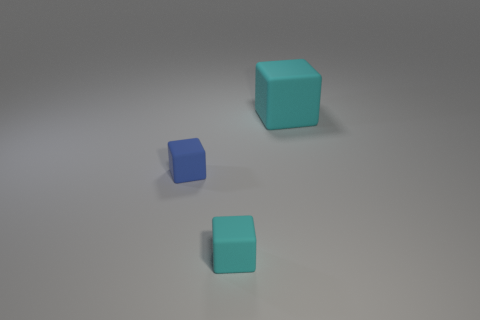Subtract all small cubes. How many cubes are left? 1 Add 1 tiny purple shiny balls. How many objects exist? 4 Subtract all purple cylinders. How many cyan cubes are left? 2 Subtract all blue cubes. How many cubes are left? 2 Subtract all small blue matte blocks. Subtract all large cyan things. How many objects are left? 1 Add 3 big blocks. How many big blocks are left? 4 Add 2 large brown blocks. How many large brown blocks exist? 2 Subtract 0 purple spheres. How many objects are left? 3 Subtract 2 cubes. How many cubes are left? 1 Subtract all red blocks. Subtract all yellow cylinders. How many blocks are left? 3 